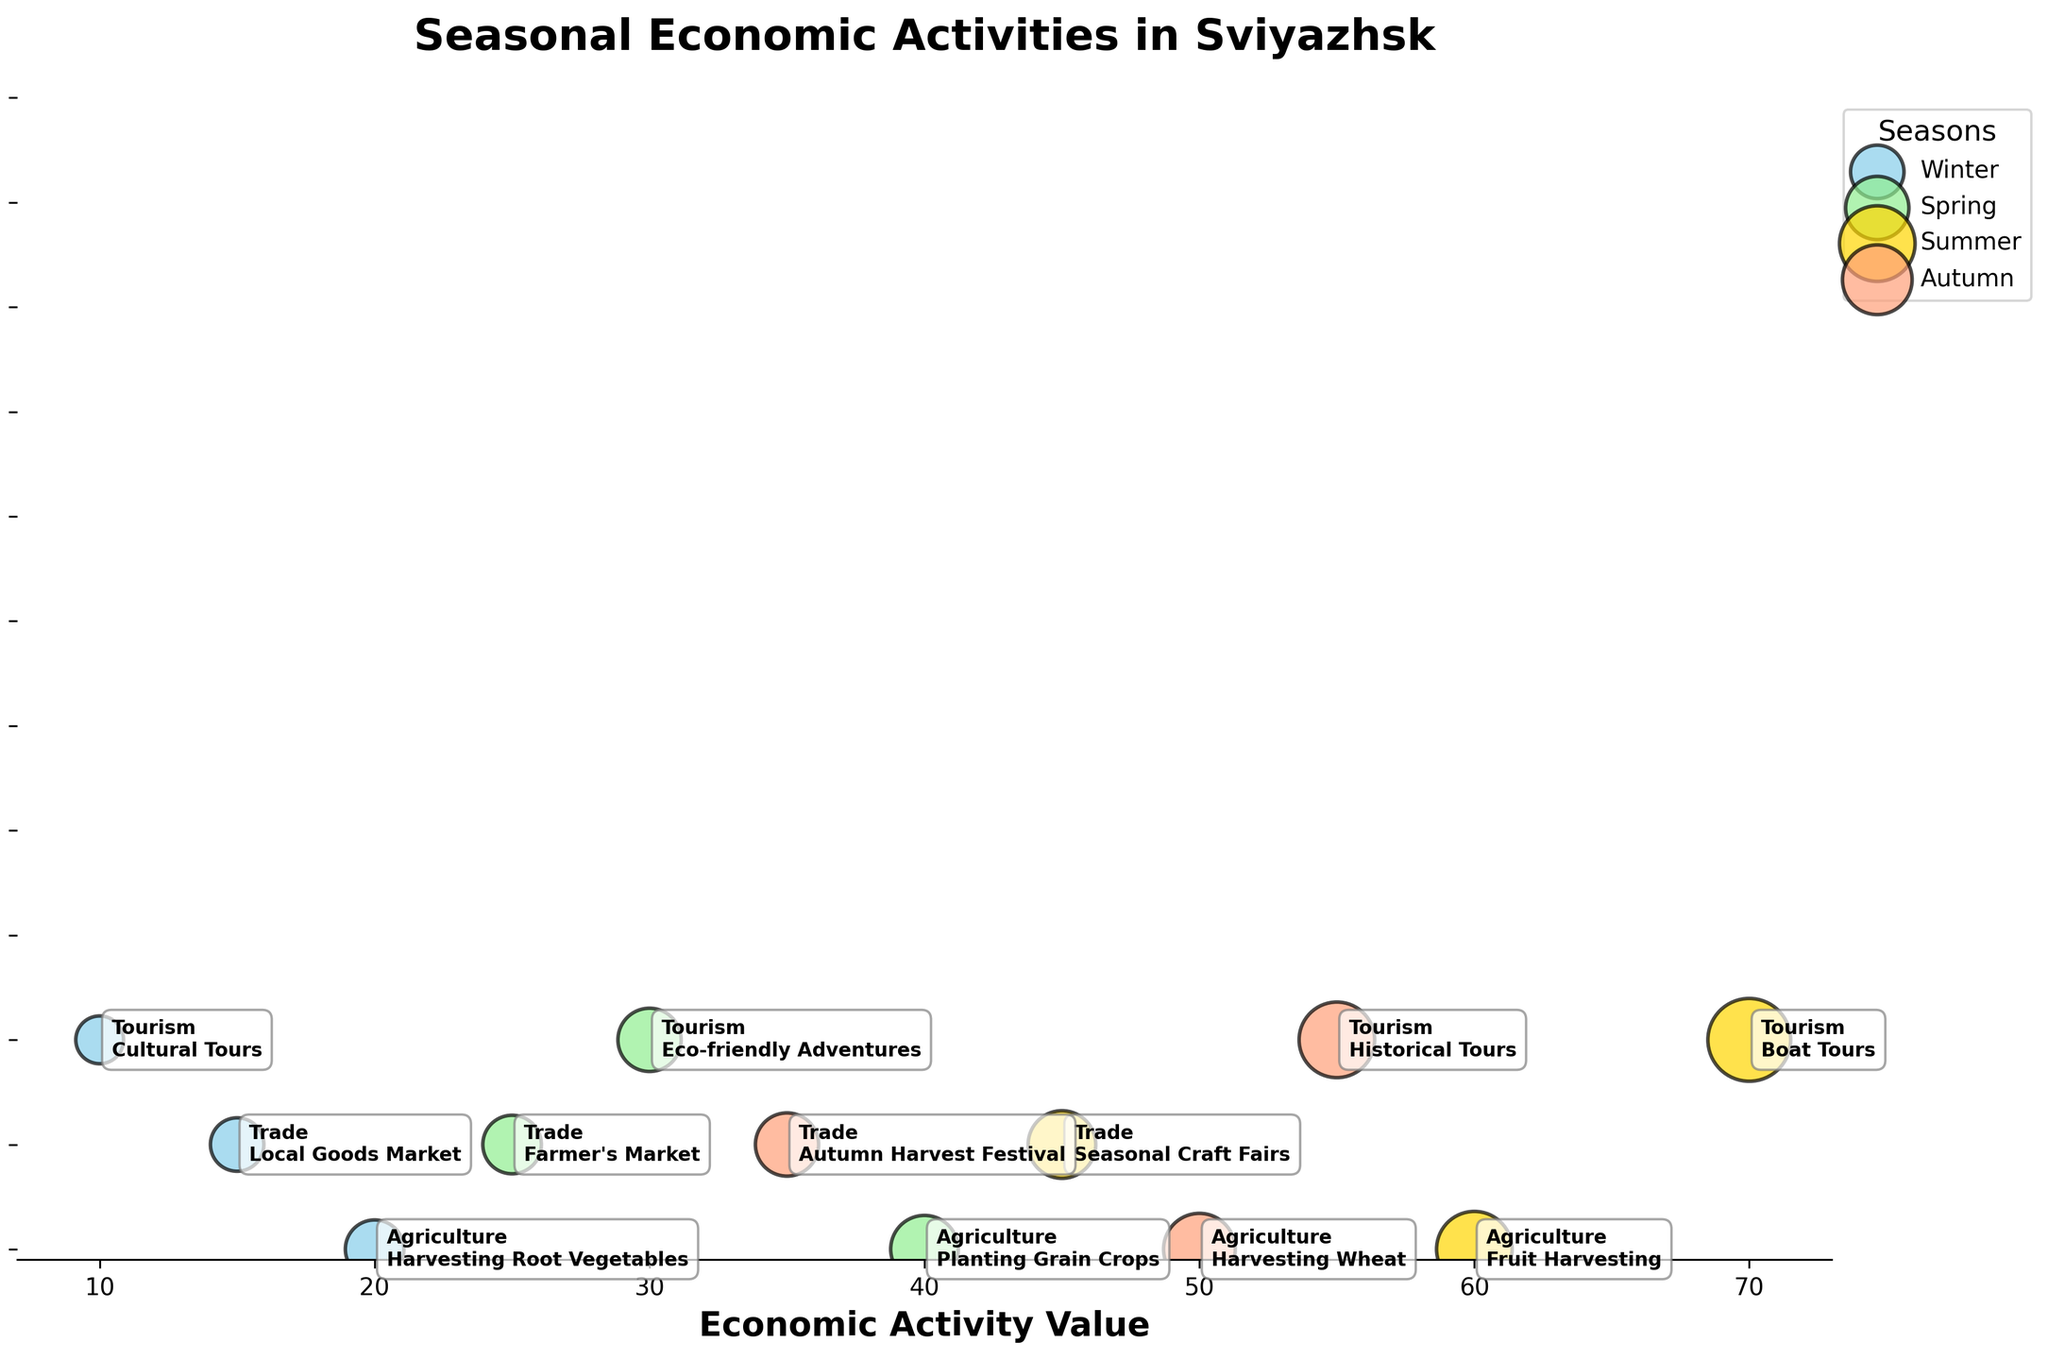What is the title of the chart? The title of the chart is indicated at the top, providing an overview of what the figure represents. The title is "Seasonal Economic Activities in Sviyazhsk".
Answer: Seasonal Economic Activities in Sviyazhsk How many economic activities are shown for the Winter season? The number of economic activities can be counted by looking at the bubbles labeled "Winter". There are three: "Harvesting Root Vegetables", "Local Goods Market", and "Cultural Tours".
Answer: 3 Which sector and activity have the largest bubble size in Summer? To find the sector and activity with the largest bubble size in Summer, look for the largest bubble among the ones labeled with Summer’s color. The largest bubble has "Tourism" and "Boat Tours".
Answer: Tourism, Boat Tours What is the economic activity value for "Fruit Harvesting" in Summer? Locate the bubble titled "Fruit Harvesting" under Summer and check its position on the x-axis. The value is 60.
Answer: 60 Compare the Agriculture activity value in Winter and Spring. Which one is higher and by how much? Find the Agriculture activity values for Winter ("Harvesting Root Vegetables" = 20) and Spring ("Planting Grain Crops" = 40). Spring's value is higher by 40 - 20 = 20.
Answer: Spring by 20 What is the total economic activity value for all Agriculture activities? Sum the values for each Agriculture activity: Winter (20), Spring (40), Summer (60), and Autumn (50). The total is 20 + 40 + 60 + 50 = 170.
Answer: 170 How do the economic activity values of "Local Goods Market" in Winter and "Autumn Harvest Festival" in Autumn compare? Check the values: Winter's "Local Goods Market" = 15, Autumn's "Autumn Harvest Festival" = 35. 35 is greater than 15.
Answer: Autumn is higher Which season has the highest total economic activity value? Sum the values for each season: Winter (45), Spring (95), Summer (175), Autumn (140). Summer has the highest total value.
Answer: Summer What are the specific values for the Tourism sector in Autumn? Look at the bubble titled "Historical Tours" under Autumn and check its position on the x-axis. The value is 55.
Answer: 55 Which season has the smallest bubble size for any activity, and what is that activity? Identify the smallest bubble size by visual inspection. It's in Winter for "Cultural Tours" (size 20).
Answer: Winter, Cultural Tours 